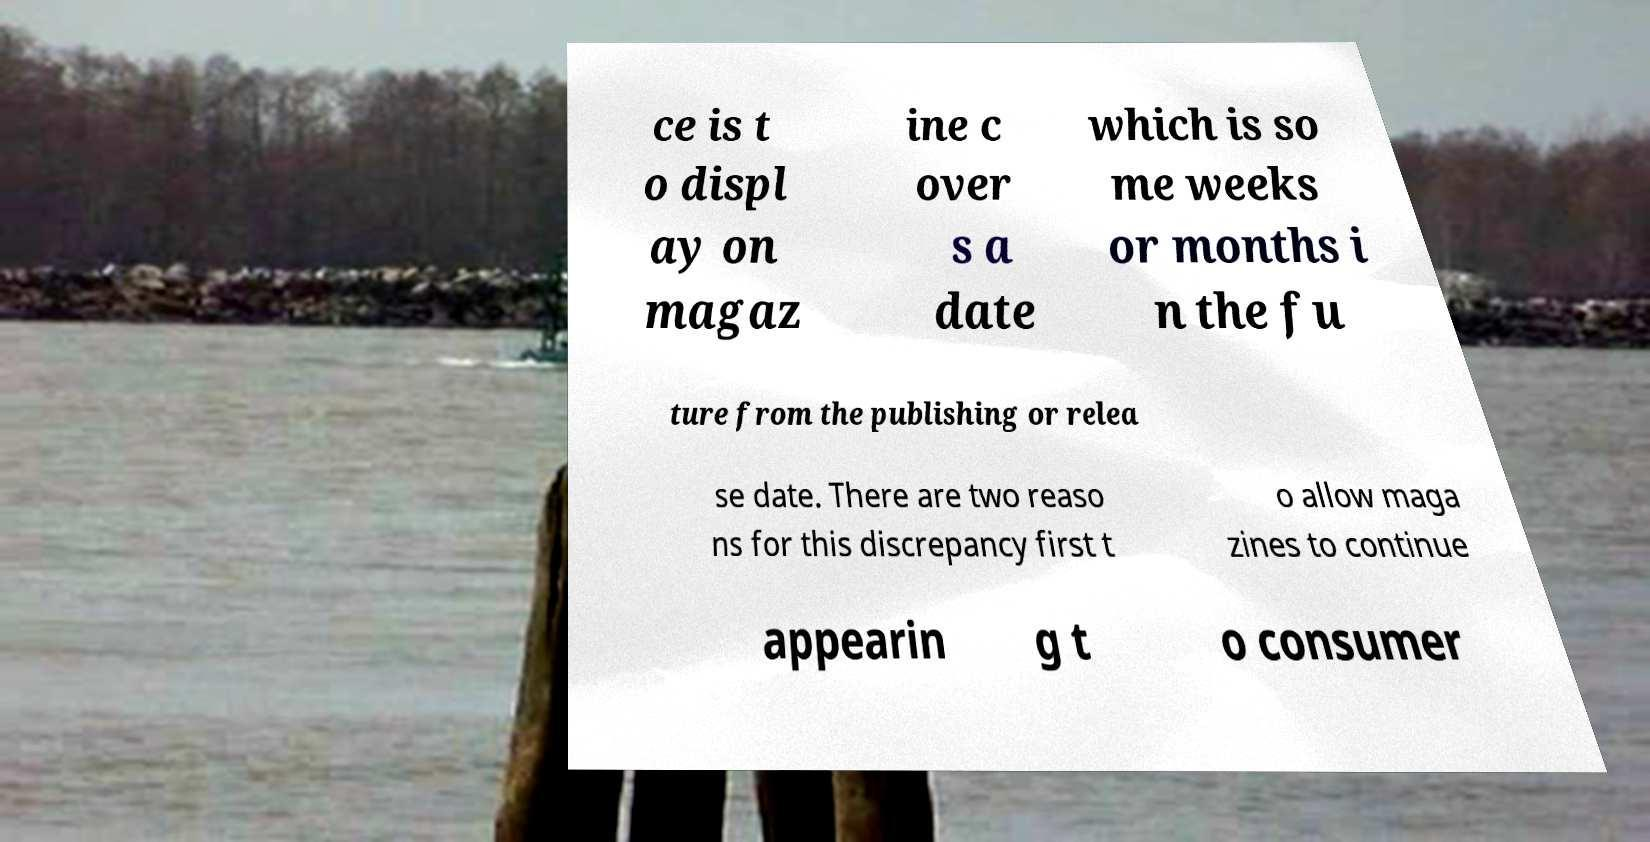For documentation purposes, I need the text within this image transcribed. Could you provide that? ce is t o displ ay on magaz ine c over s a date which is so me weeks or months i n the fu ture from the publishing or relea se date. There are two reaso ns for this discrepancy first t o allow maga zines to continue appearin g t o consumer 